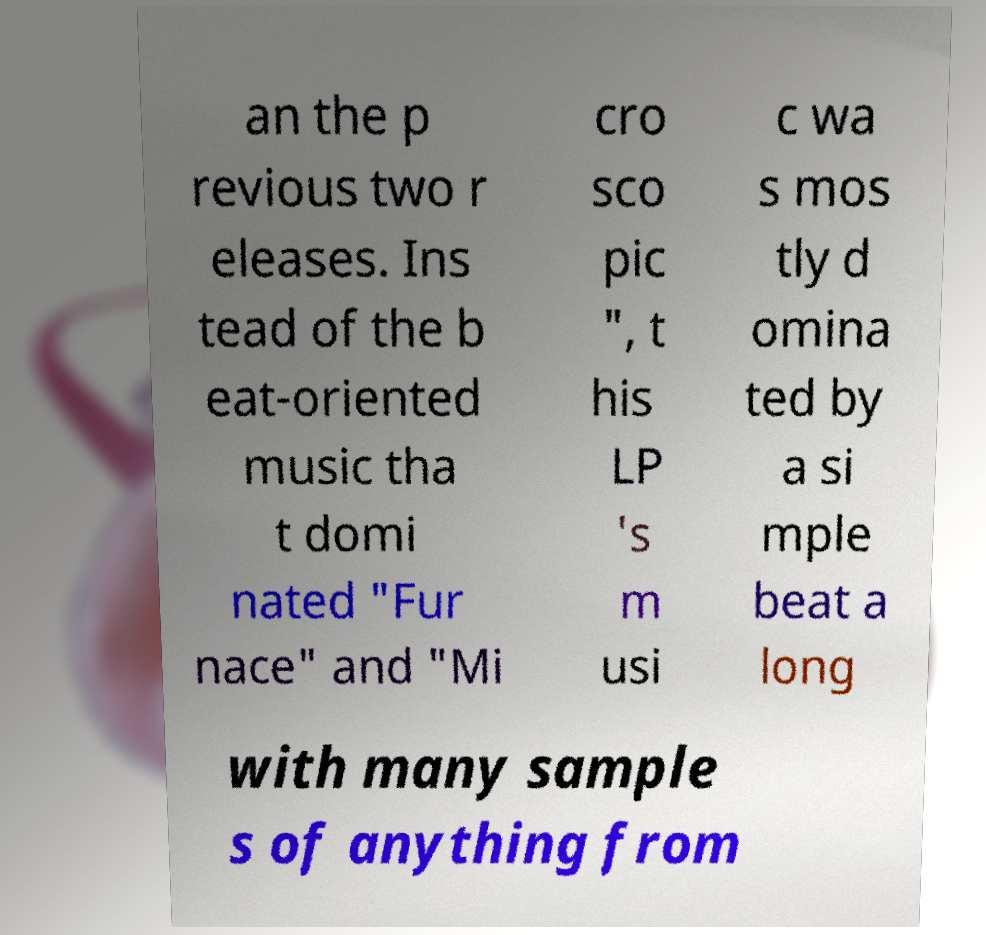Could you extract and type out the text from this image? an the p revious two r eleases. Ins tead of the b eat-oriented music tha t domi nated "Fur nace" and "Mi cro sco pic ", t his LP 's m usi c wa s mos tly d omina ted by a si mple beat a long with many sample s of anything from 